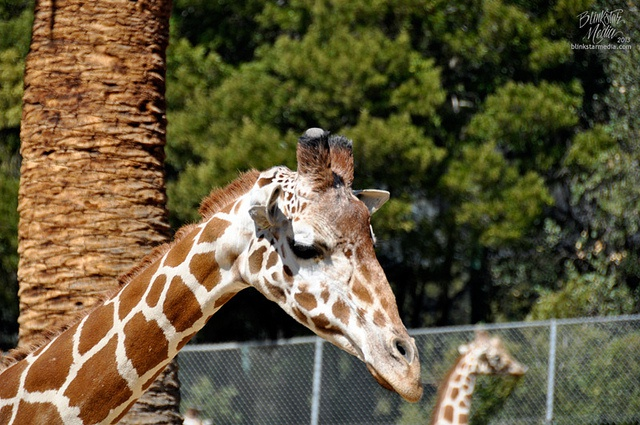Describe the objects in this image and their specific colors. I can see giraffe in darkgreen, ivory, brown, maroon, and gray tones and giraffe in darkgreen, lightgray, darkgray, and tan tones in this image. 